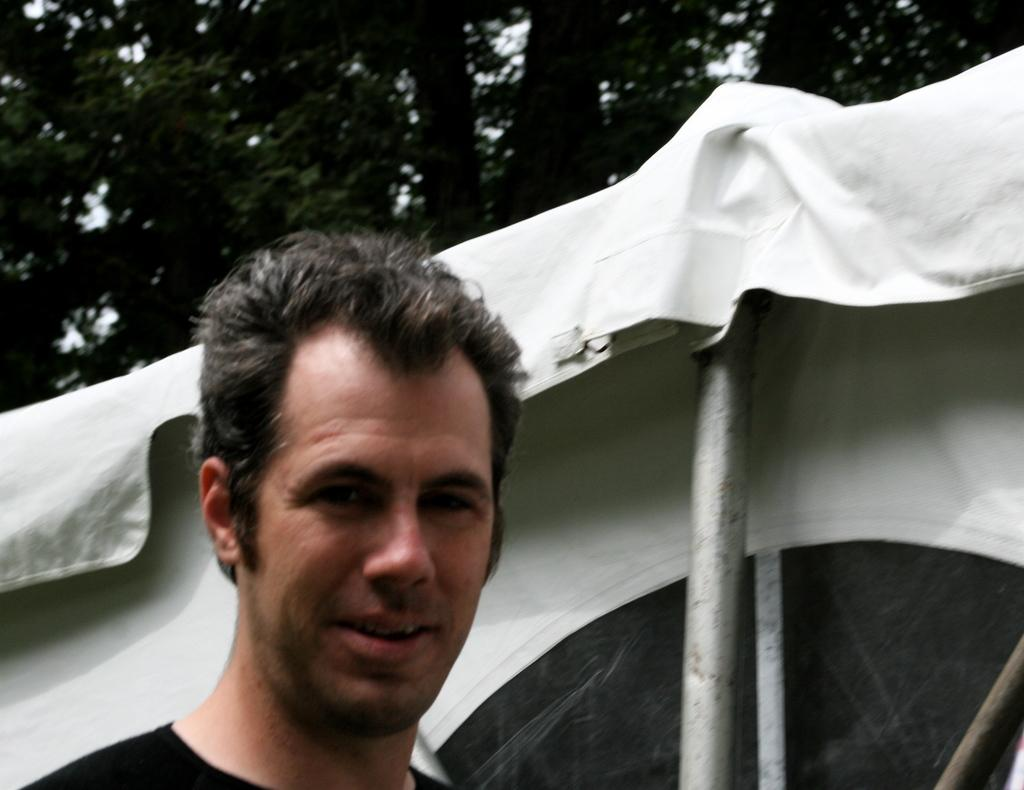Who is present in the image? There is a man in the image. What structure is located next to the man? There is a tent next to the man. What can be seen in the background of the image? There are trees in the background of the image. Where is the faucet located in the image? There is no faucet present in the image. What type of banana is the man holding in the image? There is no banana present in the image. 